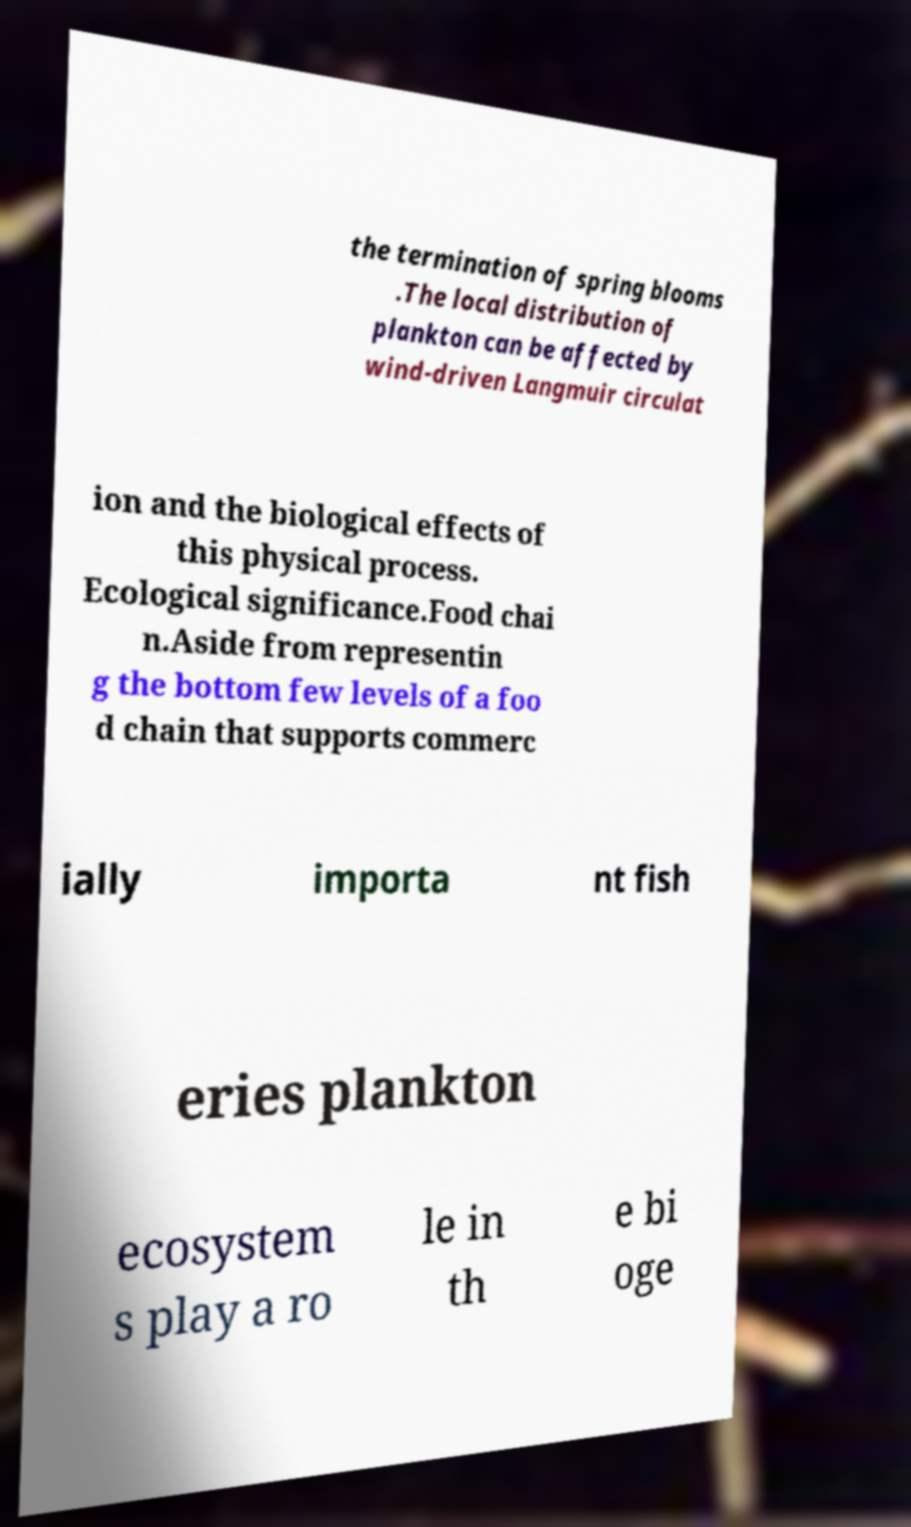Could you extract and type out the text from this image? the termination of spring blooms .The local distribution of plankton can be affected by wind-driven Langmuir circulat ion and the biological effects of this physical process. Ecological significance.Food chai n.Aside from representin g the bottom few levels of a foo d chain that supports commerc ially importa nt fish eries plankton ecosystem s play a ro le in th e bi oge 